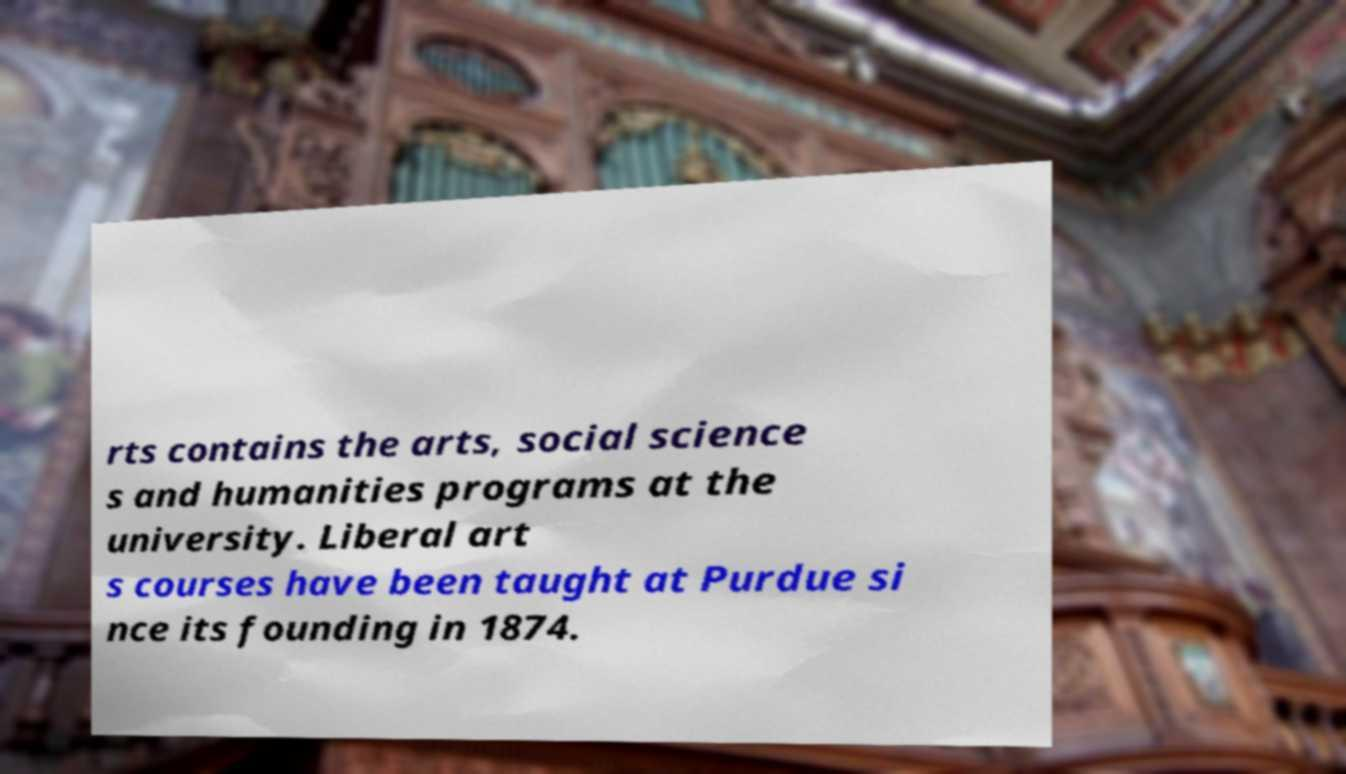For documentation purposes, I need the text within this image transcribed. Could you provide that? rts contains the arts, social science s and humanities programs at the university. Liberal art s courses have been taught at Purdue si nce its founding in 1874. 